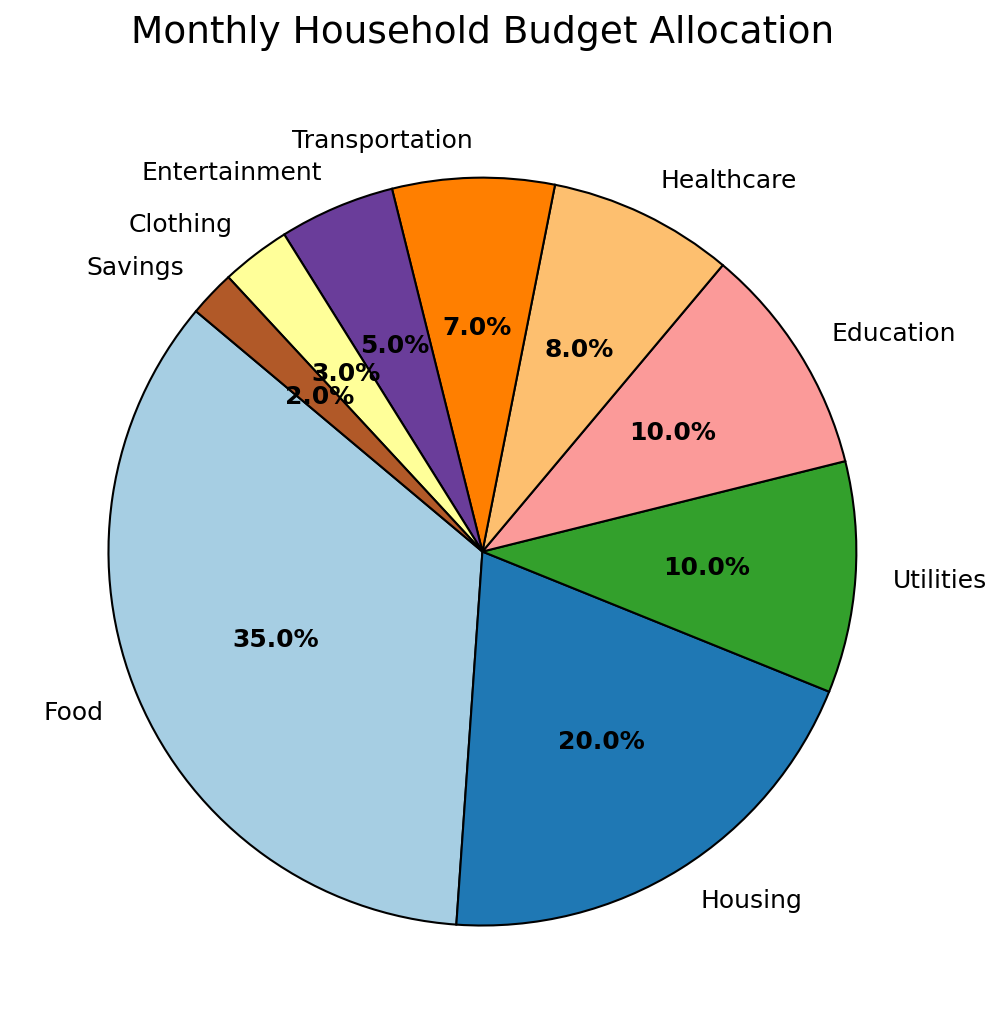What's the largest category in the household budget allocation? The largest portion of the pie chart is labeled "Food," which, based on the pie chart's labels, occupies 35% of the household budget.
Answer: Food What's the combined allocation for Food and Housing? From the pie chart, we see that Food is 35% and Housing is 20%. Adding these percentages, 35 + 20 = 55.
Answer: 55% How much more is spent on Entertainment than Savings? Entertainment occupies 5% of the budget, while Savings is 2%. Subtracting these percentages, 5 - 2 = 3.
Answer: 3% Which category has a smaller allocation: Healthcare or Transportation? From the pie chart, Healthcare occupies 8% while Transportation occupies 7%. Since 7% is less than 8%, Transportation has a smaller allocation.
Answer: Transportation What is the combined percentage for Utilities, Education, and Clothing? According to the pie chart, Utilities is 10%, Education is 10%, and Clothing is 3%. Adding these percentages: 10 + 10 + 3 = 23.
Answer: 23% Do Food and Healthcare together take up less than half of the budget? Food is 35% and Healthcare is 8%. The sum is 35 + 8 = 43, which is less than 50.
Answer: Yes Which categories each occupy less than 10% of the budget? The categories less than 10% are Utilities (10% not less), Education (10% not less), Healthcare (8%), Transportation (7%), Entertainment (5%), Clothing (3%), and Savings (2%).
Answer: Healthcare, Transportation, Entertainment, Clothing, Savings Compare the total allocation of Education and Transportation to Entertainment and Savings. Which is higher? Education is 10% and Transportation is 7%, making a total of 17%. Entertainment is 5% and Savings is 2%, making a total of 7%. 17% is greater than 7%.
Answer: Education and Transportation What percentage of the budget is spent on non-essential categories (Entertainment, Clothing, and Savings)? Entertainment is 5%, Clothing is 3%, and Savings is 2%. Adding these percentages: 5 + 3 + 2 = 10.
Answer: 10% If Healthcare costs increased by 2%, how would its new allocation compare with Housing? Current Healthcare is 8%. If it increased by 2%, it becomes 10%. Housing is 20%, 10% is still less than 20%.
Answer: Less 